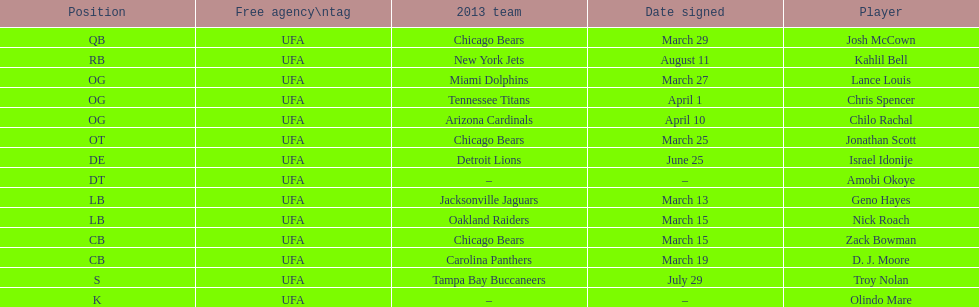Who was the previous player signed before troy nolan? Israel Idonije. 